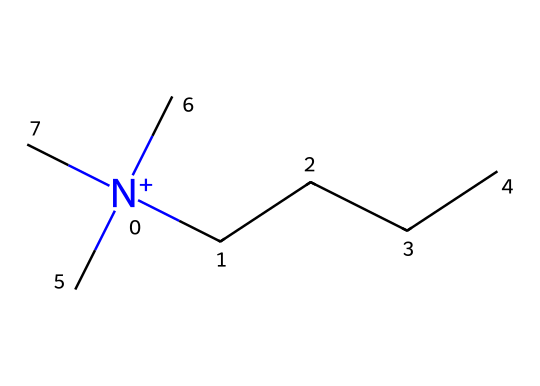What is the primary functional group in this chemical? In the provided SMILES representation, the presence of the nitrogen atom with a positive charge and surrounded by four carbon-containing alkyl groups indicates it is a quaternary ammonium compound. The quaternary nitrogen is a defining feature of this class of compounds.
Answer: quaternary ammonium How many carbon atoms are present in this molecule? By analyzing the SMILES structure, we see that there are four linear carbon chains (CCCC) and three additional carbon atoms from the methyl groups (C). Counting these gives a total of seven carbon atoms.
Answer: seven What type of chemical structure is represented by this SMILES? The SMILES indicates a positively charged nitrogen atom bonded to four alkyl groups, characterizing it as a quaternary ammonium compound, which is commonly used in disinfectants and sanitizers.
Answer: quaternary ammonium What is the total number of bonds between carbon atoms in this structure? The structure indicates that each carbon atom is bonded to neighboring carbon atoms and to the nitrogen atom. In total, there are three carbon-carbon single bonds from the chain and one from methyl groups, summing up to four carbon-carbon bonds.
Answer: four Does this compound contain any functional groups that would make it effective as a preservative? Yes, the quaternary ammonium structure, with its nitrogen atom and hydrocarbon chains, exhibits antimicrobial properties, which enable it to act as a preservative in disinfectants.
Answer: yes How does the positive charge on the nitrogen affect the properties of this compound? The positive charge on the nitrogen enhances the compound's ability to interact with microbial membranes, resulting in its effectiveness as a disinfectant by disrupting these membranes.
Answer: enhances interaction 